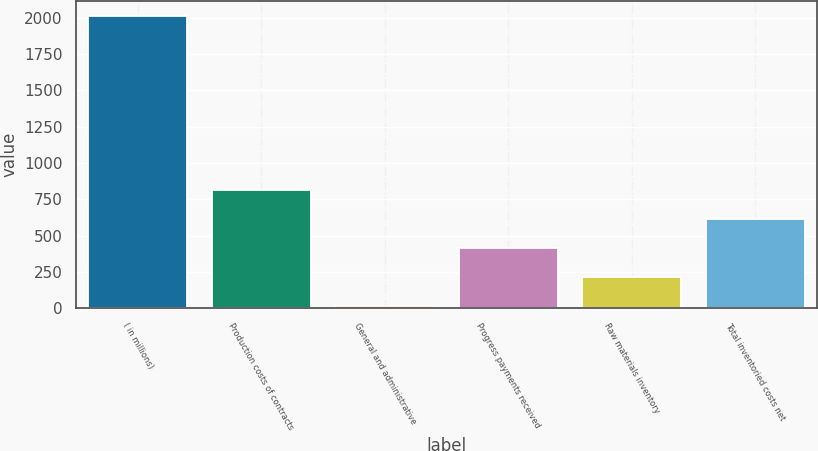<chart> <loc_0><loc_0><loc_500><loc_500><bar_chart><fcel>( in millions)<fcel>Production costs of contracts<fcel>General and administrative<fcel>Progress payments received<fcel>Raw materials inventory<fcel>Total inventoried costs net<nl><fcel>2011<fcel>813.4<fcel>15<fcel>414.2<fcel>214.6<fcel>613.8<nl></chart> 